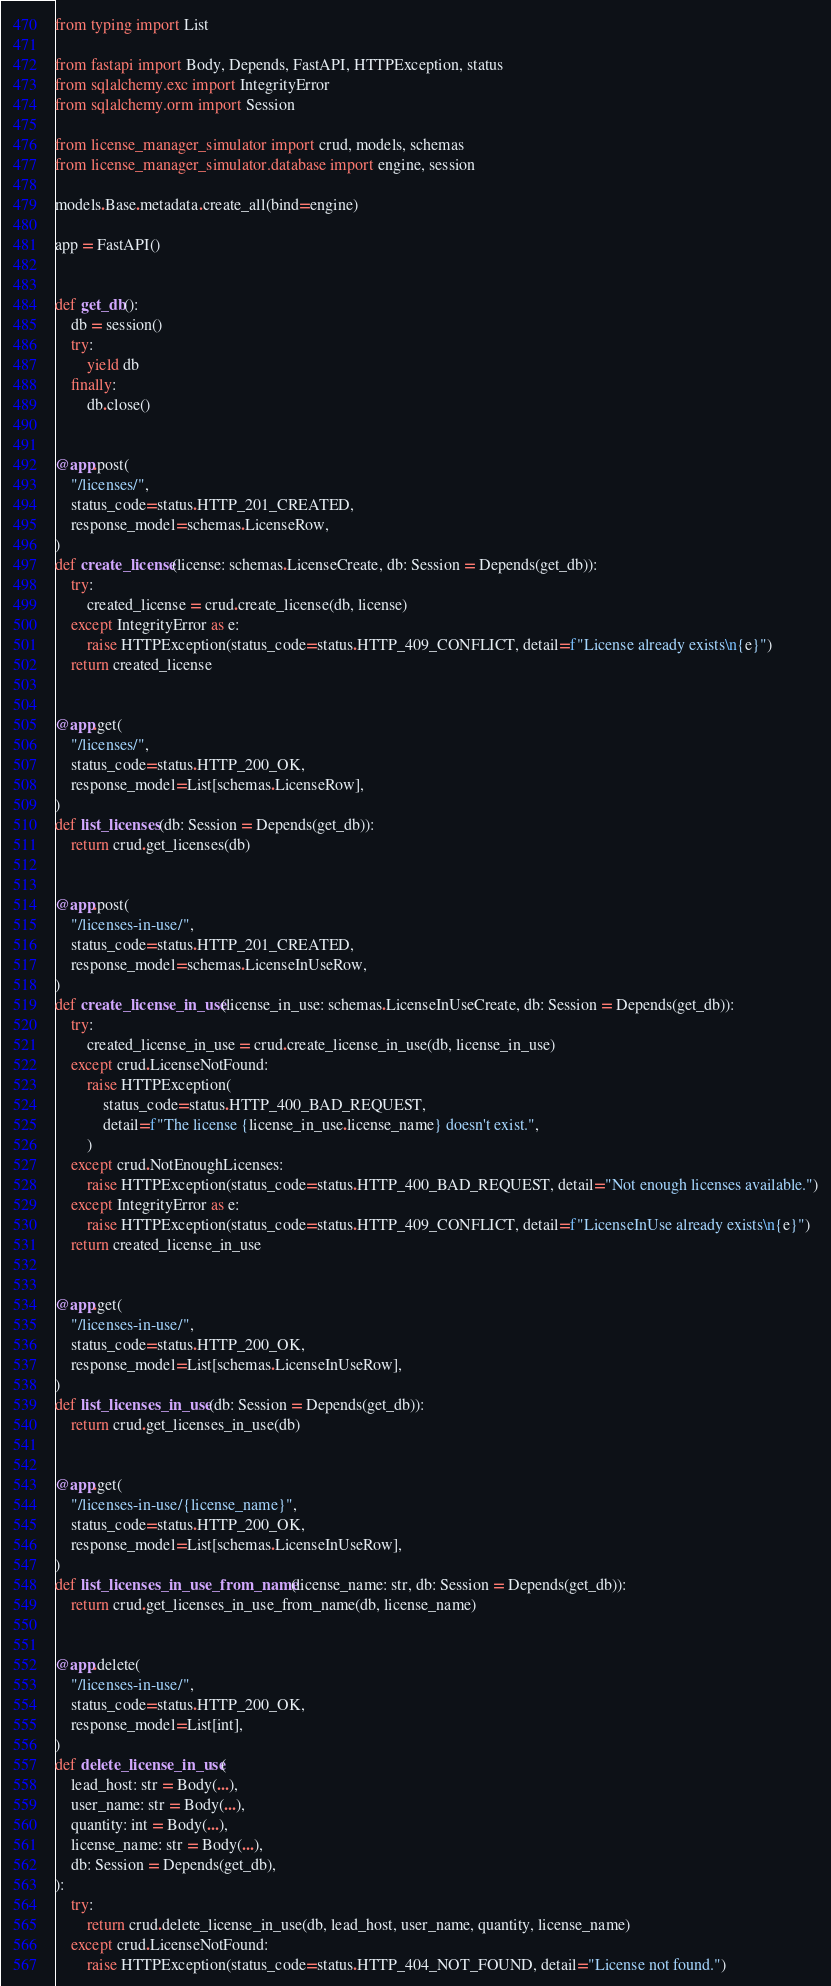Convert code to text. <code><loc_0><loc_0><loc_500><loc_500><_Python_>from typing import List

from fastapi import Body, Depends, FastAPI, HTTPException, status
from sqlalchemy.exc import IntegrityError
from sqlalchemy.orm import Session

from license_manager_simulator import crud, models, schemas
from license_manager_simulator.database import engine, session

models.Base.metadata.create_all(bind=engine)

app = FastAPI()


def get_db():
    db = session()
    try:
        yield db
    finally:
        db.close()


@app.post(
    "/licenses/",
    status_code=status.HTTP_201_CREATED,
    response_model=schemas.LicenseRow,
)
def create_license(license: schemas.LicenseCreate, db: Session = Depends(get_db)):
    try:
        created_license = crud.create_license(db, license)
    except IntegrityError as e:
        raise HTTPException(status_code=status.HTTP_409_CONFLICT, detail=f"License already exists\n{e}")
    return created_license


@app.get(
    "/licenses/",
    status_code=status.HTTP_200_OK,
    response_model=List[schemas.LicenseRow],
)
def list_licenses(db: Session = Depends(get_db)):
    return crud.get_licenses(db)


@app.post(
    "/licenses-in-use/",
    status_code=status.HTTP_201_CREATED,
    response_model=schemas.LicenseInUseRow,
)
def create_license_in_use(license_in_use: schemas.LicenseInUseCreate, db: Session = Depends(get_db)):
    try:
        created_license_in_use = crud.create_license_in_use(db, license_in_use)
    except crud.LicenseNotFound:
        raise HTTPException(
            status_code=status.HTTP_400_BAD_REQUEST,
            detail=f"The license {license_in_use.license_name} doesn't exist.",
        )
    except crud.NotEnoughLicenses:
        raise HTTPException(status_code=status.HTTP_400_BAD_REQUEST, detail="Not enough licenses available.")
    except IntegrityError as e:
        raise HTTPException(status_code=status.HTTP_409_CONFLICT, detail=f"LicenseInUse already exists\n{e}")
    return created_license_in_use


@app.get(
    "/licenses-in-use/",
    status_code=status.HTTP_200_OK,
    response_model=List[schemas.LicenseInUseRow],
)
def list_licenses_in_use(db: Session = Depends(get_db)):
    return crud.get_licenses_in_use(db)


@app.get(
    "/licenses-in-use/{license_name}",
    status_code=status.HTTP_200_OK,
    response_model=List[schemas.LicenseInUseRow],
)
def list_licenses_in_use_from_name(license_name: str, db: Session = Depends(get_db)):
    return crud.get_licenses_in_use_from_name(db, license_name)


@app.delete(
    "/licenses-in-use/",
    status_code=status.HTTP_200_OK,
    response_model=List[int],
)
def delete_license_in_use(
    lead_host: str = Body(...),
    user_name: str = Body(...),
    quantity: int = Body(...),
    license_name: str = Body(...),
    db: Session = Depends(get_db),
):
    try:
        return crud.delete_license_in_use(db, lead_host, user_name, quantity, license_name)
    except crud.LicenseNotFound:
        raise HTTPException(status_code=status.HTTP_404_NOT_FOUND, detail="License not found.")
</code> 